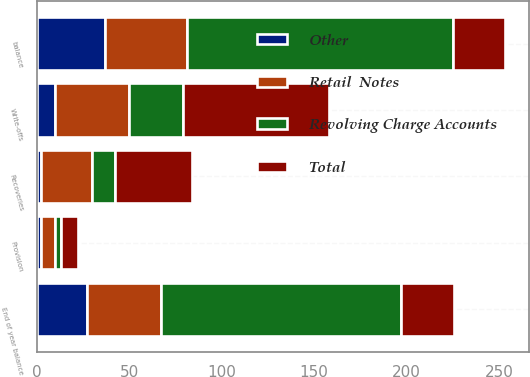<chart> <loc_0><loc_0><loc_500><loc_500><stacked_bar_chart><ecel><fcel>balance<fcel>Provision<fcel>Write-offs<fcel>Recoveries<fcel>End of year balance<nl><fcel>Revolving Charge Accounts<fcel>144<fcel>3<fcel>29<fcel>12<fcel>130<nl><fcel>Retail  Notes<fcel>44<fcel>8<fcel>40<fcel>28<fcel>40<nl><fcel>Other<fcel>37<fcel>2<fcel>10<fcel>2<fcel>27<nl><fcel>Total<fcel>28.5<fcel>9<fcel>79<fcel>42<fcel>28.5<nl></chart> 